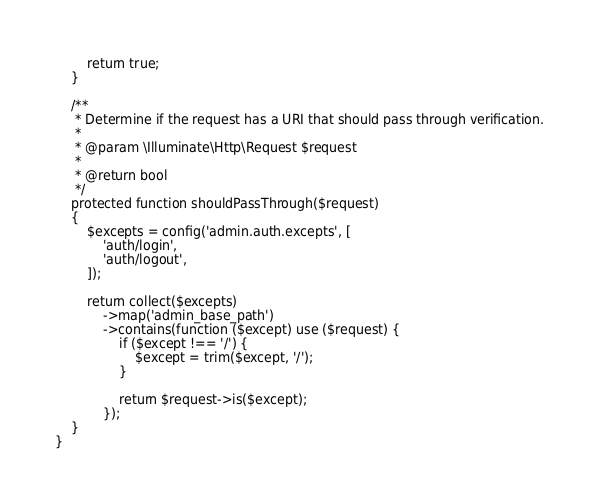Convert code to text. <code><loc_0><loc_0><loc_500><loc_500><_PHP_>
        return true;
    }

    /**
     * Determine if the request has a URI that should pass through verification.
     *
     * @param \Illuminate\Http\Request $request
     *
     * @return bool
     */
    protected function shouldPassThrough($request)
    {
        $excepts = config('admin.auth.excepts', [
            'auth/login',
            'auth/logout',
        ]);

        return collect($excepts)
            ->map('admin_base_path')
            ->contains(function ($except) use ($request) {
                if ($except !== '/') {
                    $except = trim($except, '/');
                }

                return $request->is($except);
            });
    }
}
</code> 